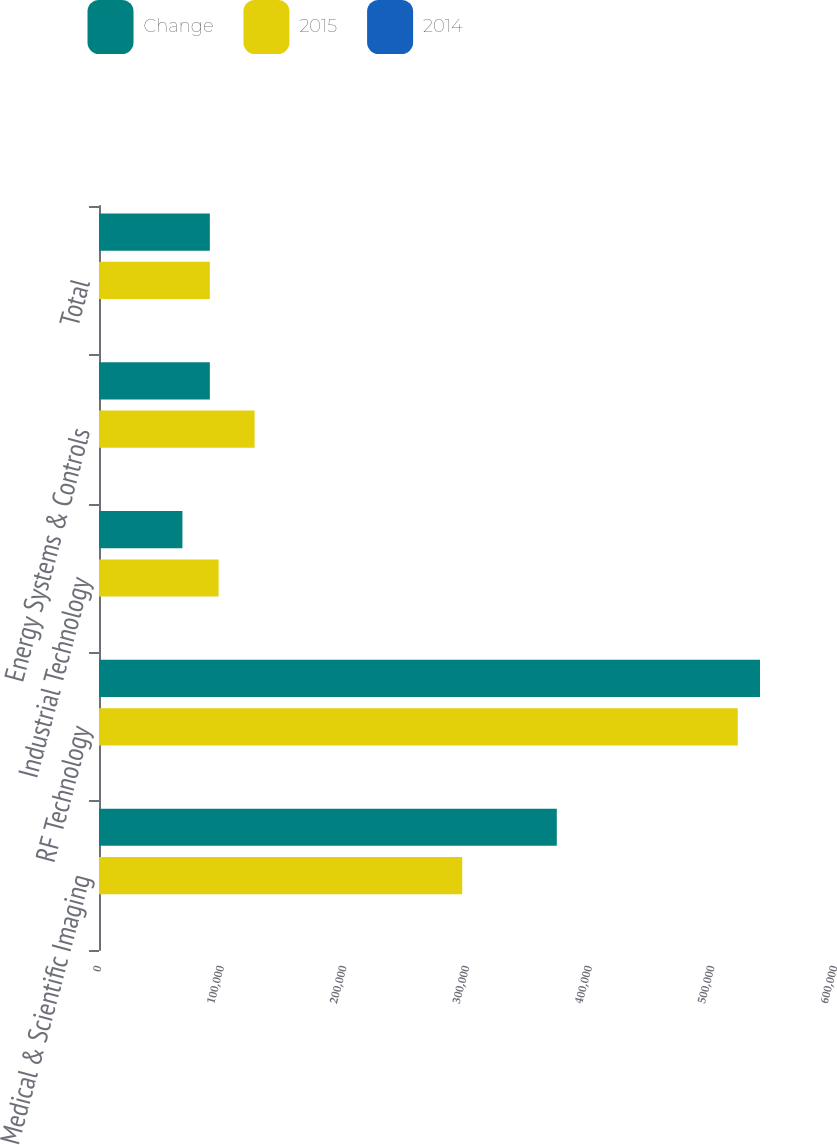Convert chart. <chart><loc_0><loc_0><loc_500><loc_500><stacked_bar_chart><ecel><fcel>Medical & Scientific Imaging<fcel>RF Technology<fcel>Industrial Technology<fcel>Energy Systems & Controls<fcel>Total<nl><fcel>Change<fcel>373213<fcel>538877<fcel>68002<fcel>90365<fcel>90365<nl><fcel>2015<fcel>296098<fcel>520727<fcel>97507<fcel>126838<fcel>90365<nl><fcel>2014<fcel>26<fcel>3.5<fcel>30.3<fcel>28.8<fcel>2.8<nl></chart> 